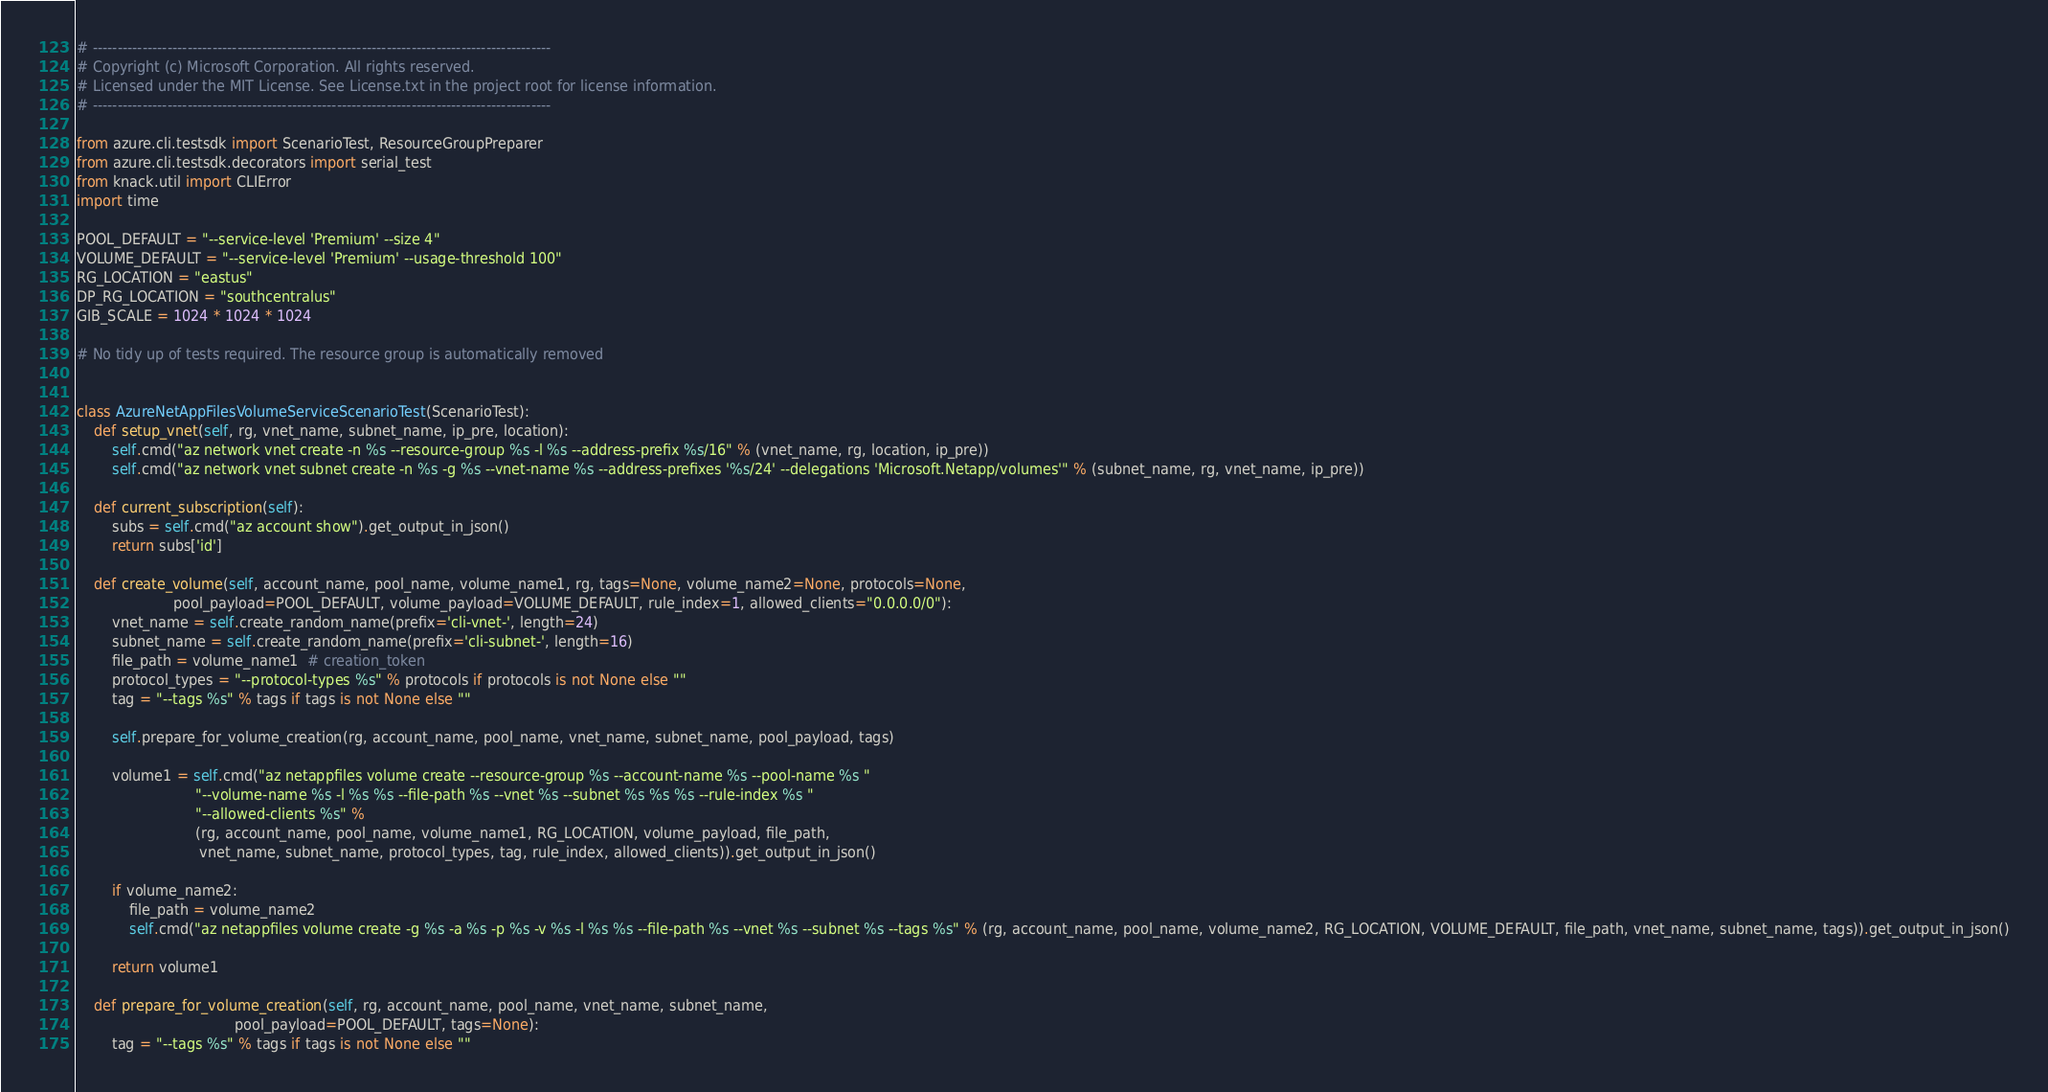<code> <loc_0><loc_0><loc_500><loc_500><_Python_># --------------------------------------------------------------------------------------------
# Copyright (c) Microsoft Corporation. All rights reserved.
# Licensed under the MIT License. See License.txt in the project root for license information.
# --------------------------------------------------------------------------------------------

from azure.cli.testsdk import ScenarioTest, ResourceGroupPreparer
from azure.cli.testsdk.decorators import serial_test
from knack.util import CLIError
import time

POOL_DEFAULT = "--service-level 'Premium' --size 4"
VOLUME_DEFAULT = "--service-level 'Premium' --usage-threshold 100"
RG_LOCATION = "eastus"
DP_RG_LOCATION = "southcentralus"
GIB_SCALE = 1024 * 1024 * 1024

# No tidy up of tests required. The resource group is automatically removed


class AzureNetAppFilesVolumeServiceScenarioTest(ScenarioTest):
    def setup_vnet(self, rg, vnet_name, subnet_name, ip_pre, location):
        self.cmd("az network vnet create -n %s --resource-group %s -l %s --address-prefix %s/16" % (vnet_name, rg, location, ip_pre))
        self.cmd("az network vnet subnet create -n %s -g %s --vnet-name %s --address-prefixes '%s/24' --delegations 'Microsoft.Netapp/volumes'" % (subnet_name, rg, vnet_name, ip_pre))

    def current_subscription(self):
        subs = self.cmd("az account show").get_output_in_json()
        return subs['id']

    def create_volume(self, account_name, pool_name, volume_name1, rg, tags=None, volume_name2=None, protocols=None,
                      pool_payload=POOL_DEFAULT, volume_payload=VOLUME_DEFAULT, rule_index=1, allowed_clients="0.0.0.0/0"):
        vnet_name = self.create_random_name(prefix='cli-vnet-', length=24)
        subnet_name = self.create_random_name(prefix='cli-subnet-', length=16)
        file_path = volume_name1  # creation_token
        protocol_types = "--protocol-types %s" % protocols if protocols is not None else ""
        tag = "--tags %s" % tags if tags is not None else ""

        self.prepare_for_volume_creation(rg, account_name, pool_name, vnet_name, subnet_name, pool_payload, tags)

        volume1 = self.cmd("az netappfiles volume create --resource-group %s --account-name %s --pool-name %s "
                           "--volume-name %s -l %s %s --file-path %s --vnet %s --subnet %s %s %s --rule-index %s "
                           "--allowed-clients %s" %
                           (rg, account_name, pool_name, volume_name1, RG_LOCATION, volume_payload, file_path,
                            vnet_name, subnet_name, protocol_types, tag, rule_index, allowed_clients)).get_output_in_json()

        if volume_name2:
            file_path = volume_name2
            self.cmd("az netappfiles volume create -g %s -a %s -p %s -v %s -l %s %s --file-path %s --vnet %s --subnet %s --tags %s" % (rg, account_name, pool_name, volume_name2, RG_LOCATION, VOLUME_DEFAULT, file_path, vnet_name, subnet_name, tags)).get_output_in_json()

        return volume1

    def prepare_for_volume_creation(self, rg, account_name, pool_name, vnet_name, subnet_name,
                                    pool_payload=POOL_DEFAULT, tags=None):
        tag = "--tags %s" % tags if tags is not None else ""</code> 